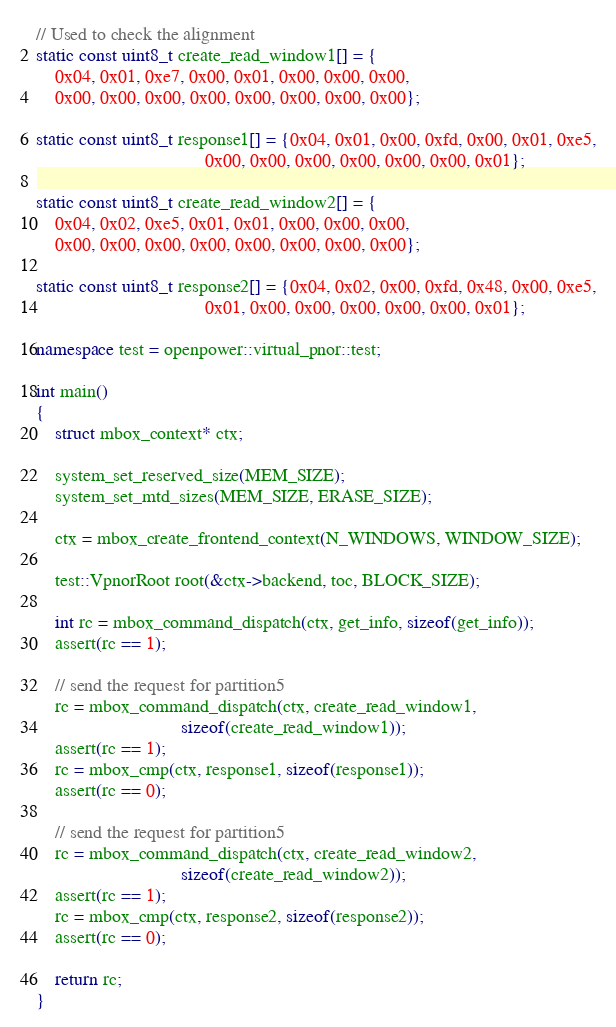<code> <loc_0><loc_0><loc_500><loc_500><_C++_>// Used to check the alignment
static const uint8_t create_read_window1[] = {
    0x04, 0x01, 0xe7, 0x00, 0x01, 0x00, 0x00, 0x00,
    0x00, 0x00, 0x00, 0x00, 0x00, 0x00, 0x00, 0x00};

static const uint8_t response1[] = {0x04, 0x01, 0x00, 0xfd, 0x00, 0x01, 0xe5,
                                    0x00, 0x00, 0x00, 0x00, 0x00, 0x00, 0x01};

static const uint8_t create_read_window2[] = {
    0x04, 0x02, 0xe5, 0x01, 0x01, 0x00, 0x00, 0x00,
    0x00, 0x00, 0x00, 0x00, 0x00, 0x00, 0x00, 0x00};

static const uint8_t response2[] = {0x04, 0x02, 0x00, 0xfd, 0x48, 0x00, 0xe5,
                                    0x01, 0x00, 0x00, 0x00, 0x00, 0x00, 0x01};

namespace test = openpower::virtual_pnor::test;

int main()
{
    struct mbox_context* ctx;

    system_set_reserved_size(MEM_SIZE);
    system_set_mtd_sizes(MEM_SIZE, ERASE_SIZE);

    ctx = mbox_create_frontend_context(N_WINDOWS, WINDOW_SIZE);

    test::VpnorRoot root(&ctx->backend, toc, BLOCK_SIZE);

    int rc = mbox_command_dispatch(ctx, get_info, sizeof(get_info));
    assert(rc == 1);

    // send the request for partition5
    rc = mbox_command_dispatch(ctx, create_read_window1,
                               sizeof(create_read_window1));
    assert(rc == 1);
    rc = mbox_cmp(ctx, response1, sizeof(response1));
    assert(rc == 0);

    // send the request for partition5
    rc = mbox_command_dispatch(ctx, create_read_window2,
                               sizeof(create_read_window2));
    assert(rc == 1);
    rc = mbox_cmp(ctx, response2, sizeof(response2));
    assert(rc == 0);

    return rc;
}
</code> 